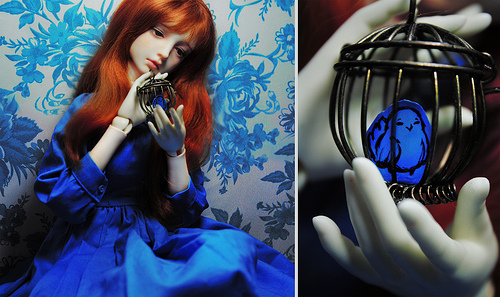<image>
Can you confirm if the bird is in the cage? Yes. The bird is contained within or inside the cage, showing a containment relationship. 